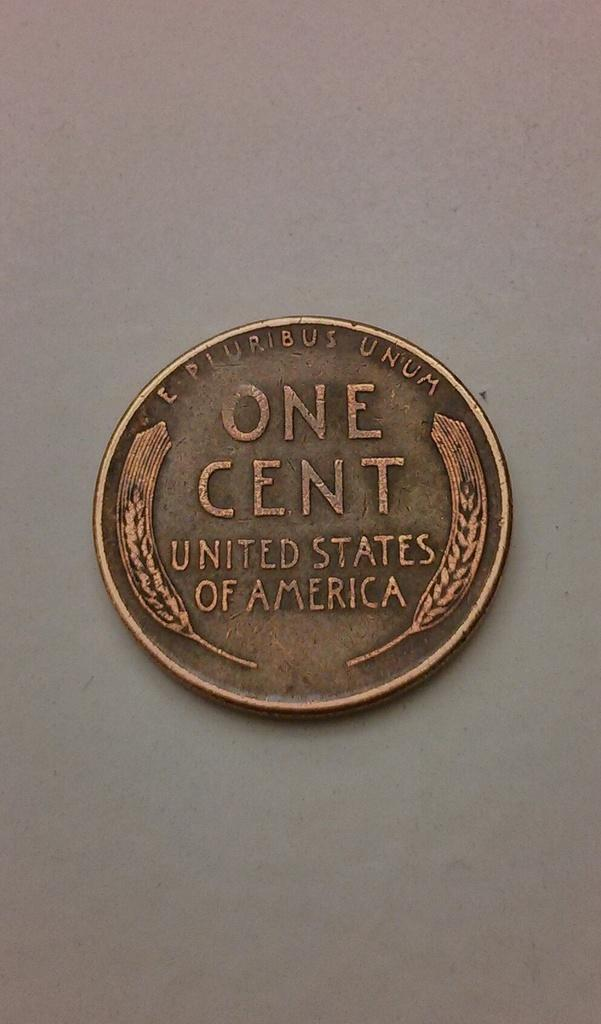<image>
Give a short and clear explanation of the subsequent image. A wheat penny that says One Cent on the back side which is facing up. 